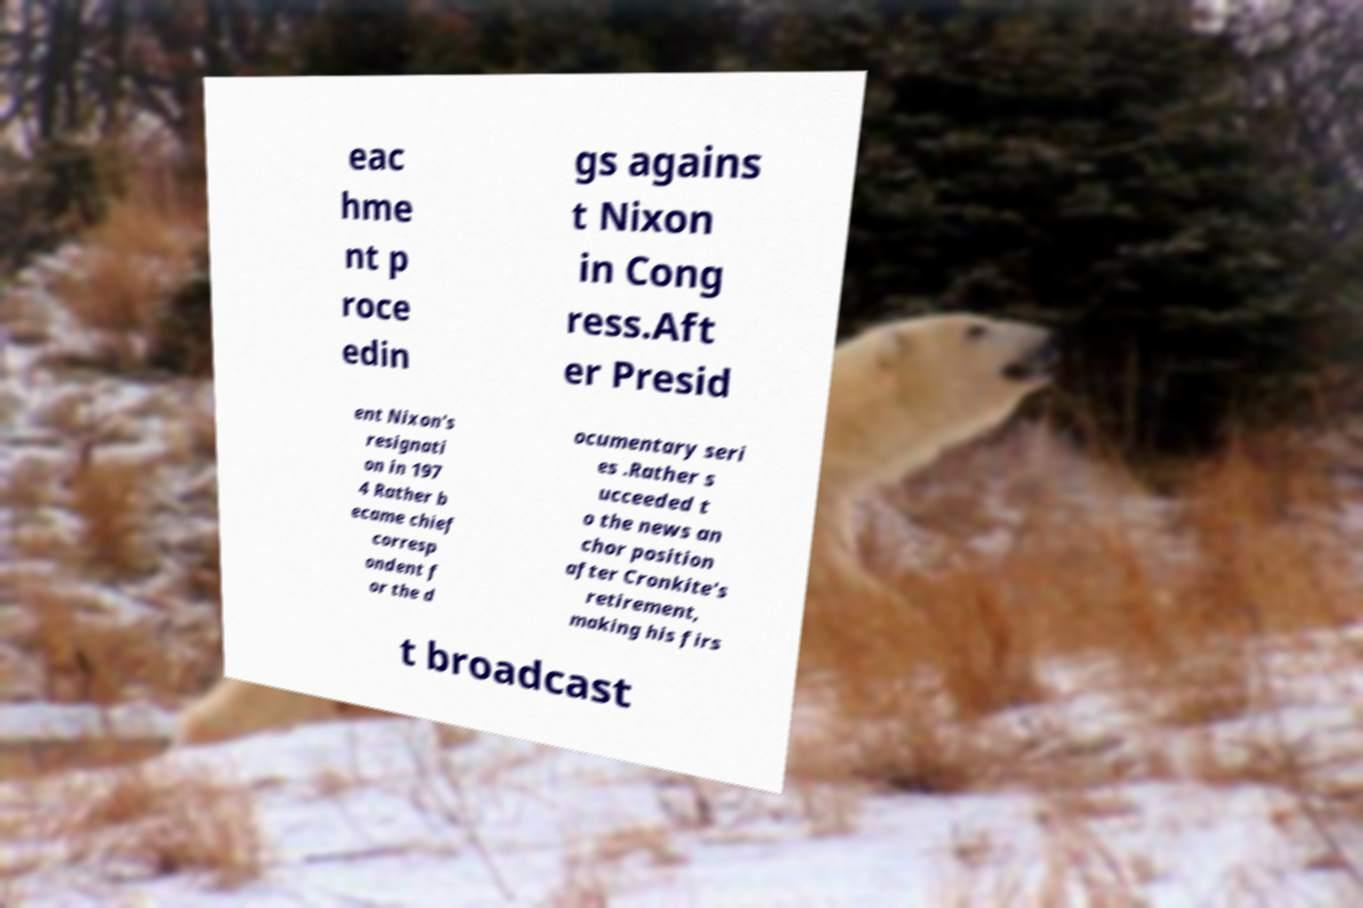I need the written content from this picture converted into text. Can you do that? eac hme nt p roce edin gs agains t Nixon in Cong ress.Aft er Presid ent Nixon's resignati on in 197 4 Rather b ecame chief corresp ondent f or the d ocumentary seri es .Rather s ucceeded t o the news an chor position after Cronkite's retirement, making his firs t broadcast 